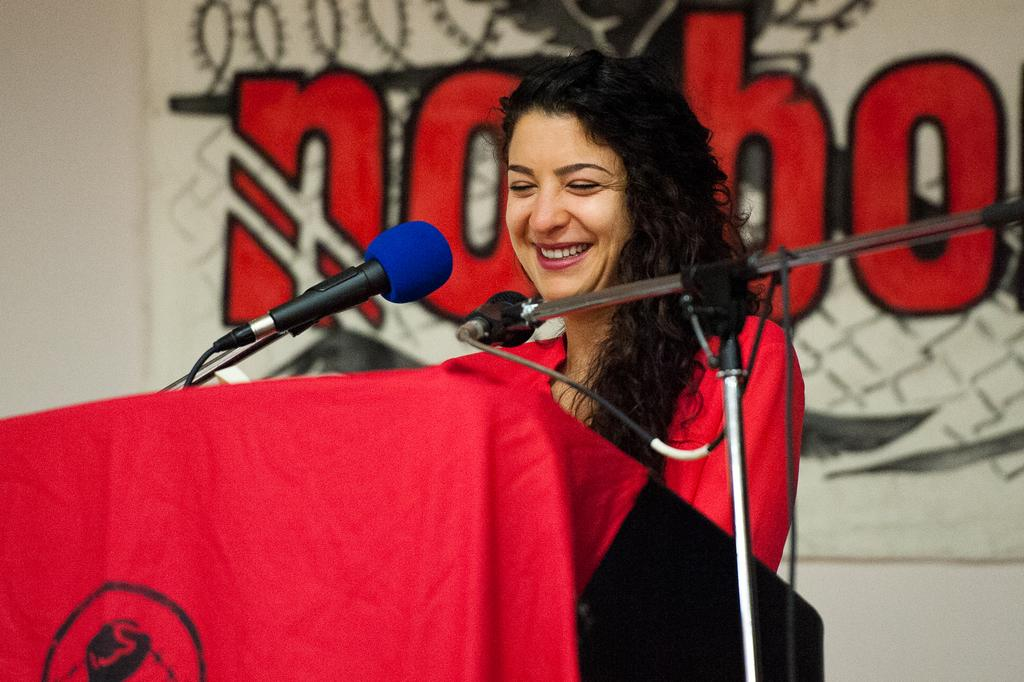Who is the main subject in the image? There is a woman in the image. What is the woman's facial expression? The woman is smiling. What object is in front of the woman? There is a podium in front of the woman. What might the woman be using to amplify her voice? There are microphones present in the image. What type of door can be seen in the background of the image? There is no door visible in the image; it only features a woman, a podium, and microphones. 